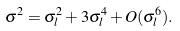<formula> <loc_0><loc_0><loc_500><loc_500>\sigma ^ { 2 } = \sigma _ { l } ^ { 2 } + 3 \sigma _ { l } ^ { 4 } + O ( \sigma _ { l } ^ { 6 } ) .</formula> 